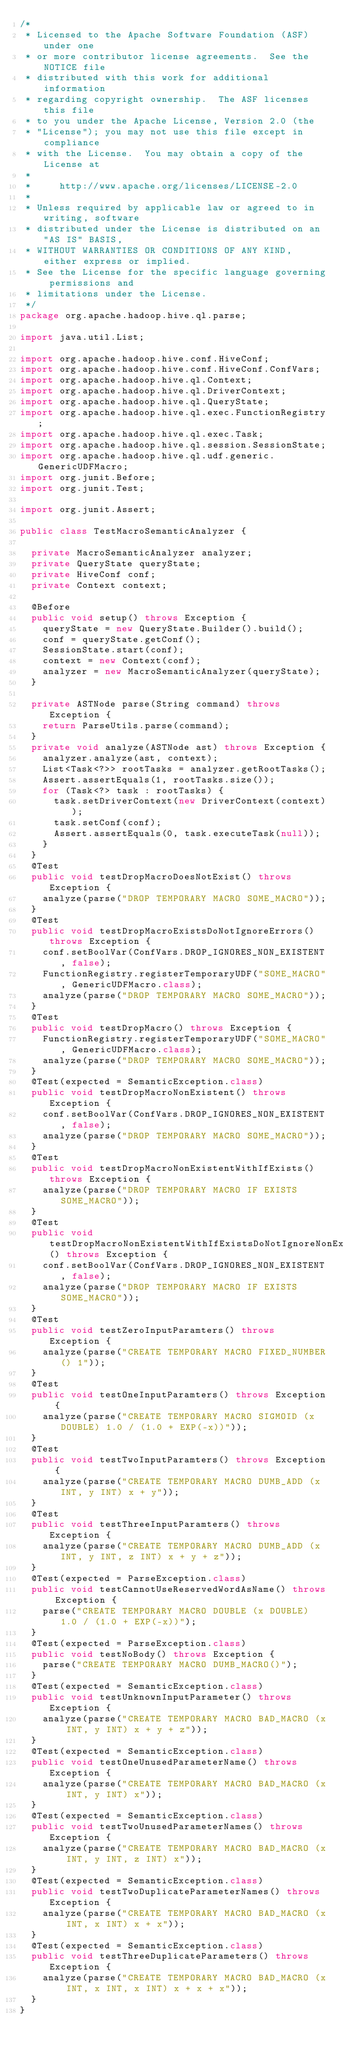Convert code to text. <code><loc_0><loc_0><loc_500><loc_500><_Java_>/*
 * Licensed to the Apache Software Foundation (ASF) under one
 * or more contributor license agreements.  See the NOTICE file
 * distributed with this work for additional information
 * regarding copyright ownership.  The ASF licenses this file
 * to you under the Apache License, Version 2.0 (the
 * "License"); you may not use this file except in compliance
 * with the License.  You may obtain a copy of the License at
 *
 *     http://www.apache.org/licenses/LICENSE-2.0
 *
 * Unless required by applicable law or agreed to in writing, software
 * distributed under the License is distributed on an "AS IS" BASIS,
 * WITHOUT WARRANTIES OR CONDITIONS OF ANY KIND, either express or implied.
 * See the License for the specific language governing permissions and
 * limitations under the License.
 */
package org.apache.hadoop.hive.ql.parse;

import java.util.List;

import org.apache.hadoop.hive.conf.HiveConf;
import org.apache.hadoop.hive.conf.HiveConf.ConfVars;
import org.apache.hadoop.hive.ql.Context;
import org.apache.hadoop.hive.ql.DriverContext;
import org.apache.hadoop.hive.ql.QueryState;
import org.apache.hadoop.hive.ql.exec.FunctionRegistry;
import org.apache.hadoop.hive.ql.exec.Task;
import org.apache.hadoop.hive.ql.session.SessionState;
import org.apache.hadoop.hive.ql.udf.generic.GenericUDFMacro;
import org.junit.Before;
import org.junit.Test;

import org.junit.Assert;

public class TestMacroSemanticAnalyzer {

  private MacroSemanticAnalyzer analyzer;
  private QueryState queryState;
  private HiveConf conf;
  private Context context;

  @Before
  public void setup() throws Exception {
    queryState = new QueryState.Builder().build();
    conf = queryState.getConf();
    SessionState.start(conf);
    context = new Context(conf);
    analyzer = new MacroSemanticAnalyzer(queryState);
  }

  private ASTNode parse(String command) throws Exception {
    return ParseUtils.parse(command);
  }
  private void analyze(ASTNode ast) throws Exception {
    analyzer.analyze(ast, context);
    List<Task<?>> rootTasks = analyzer.getRootTasks();
    Assert.assertEquals(1, rootTasks.size());
    for (Task<?> task : rootTasks) {
      task.setDriverContext(new DriverContext(context));
      task.setConf(conf);
      Assert.assertEquals(0, task.executeTask(null));
    }
  }
  @Test
  public void testDropMacroDoesNotExist() throws Exception {
    analyze(parse("DROP TEMPORARY MACRO SOME_MACRO"));
  }
  @Test
  public void testDropMacroExistsDoNotIgnoreErrors() throws Exception {
    conf.setBoolVar(ConfVars.DROP_IGNORES_NON_EXISTENT, false);
    FunctionRegistry.registerTemporaryUDF("SOME_MACRO", GenericUDFMacro.class);
    analyze(parse("DROP TEMPORARY MACRO SOME_MACRO"));
  }
  @Test
  public void testDropMacro() throws Exception {
    FunctionRegistry.registerTemporaryUDF("SOME_MACRO", GenericUDFMacro.class);
    analyze(parse("DROP TEMPORARY MACRO SOME_MACRO"));
  }
  @Test(expected = SemanticException.class)
  public void testDropMacroNonExistent() throws Exception {
    conf.setBoolVar(ConfVars.DROP_IGNORES_NON_EXISTENT, false);
    analyze(parse("DROP TEMPORARY MACRO SOME_MACRO"));
  }
  @Test
  public void testDropMacroNonExistentWithIfExists() throws Exception {
    analyze(parse("DROP TEMPORARY MACRO IF EXISTS SOME_MACRO"));
  }
  @Test
  public void testDropMacroNonExistentWithIfExistsDoNotIgnoreNonExistent() throws Exception {
    conf.setBoolVar(ConfVars.DROP_IGNORES_NON_EXISTENT, false);
    analyze(parse("DROP TEMPORARY MACRO IF EXISTS SOME_MACRO"));
  }
  @Test
  public void testZeroInputParamters() throws Exception {
    analyze(parse("CREATE TEMPORARY MACRO FIXED_NUMBER() 1"));
  }
  @Test
  public void testOneInputParamters() throws Exception {
    analyze(parse("CREATE TEMPORARY MACRO SIGMOID (x DOUBLE) 1.0 / (1.0 + EXP(-x))"));
  }
  @Test
  public void testTwoInputParamters() throws Exception {
    analyze(parse("CREATE TEMPORARY MACRO DUMB_ADD (x INT, y INT) x + y"));
  }
  @Test
  public void testThreeInputParamters() throws Exception {
    analyze(parse("CREATE TEMPORARY MACRO DUMB_ADD (x INT, y INT, z INT) x + y + z"));
  }
  @Test(expected = ParseException.class)
  public void testCannotUseReservedWordAsName() throws Exception {
    parse("CREATE TEMPORARY MACRO DOUBLE (x DOUBLE) 1.0 / (1.0 + EXP(-x))");
  }
  @Test(expected = ParseException.class)
  public void testNoBody() throws Exception {
    parse("CREATE TEMPORARY MACRO DUMB_MACRO()");
  }
  @Test(expected = SemanticException.class)
  public void testUnknownInputParameter() throws Exception {
    analyze(parse("CREATE TEMPORARY MACRO BAD_MACRO (x INT, y INT) x + y + z"));
  }
  @Test(expected = SemanticException.class)
  public void testOneUnusedParameterName() throws Exception {
    analyze(parse("CREATE TEMPORARY MACRO BAD_MACRO (x INT, y INT) x"));
  }
  @Test(expected = SemanticException.class)
  public void testTwoUnusedParameterNames() throws Exception {
    analyze(parse("CREATE TEMPORARY MACRO BAD_MACRO (x INT, y INT, z INT) x"));
  }
  @Test(expected = SemanticException.class)
  public void testTwoDuplicateParameterNames() throws Exception {
    analyze(parse("CREATE TEMPORARY MACRO BAD_MACRO (x INT, x INT) x + x"));
  }
  @Test(expected = SemanticException.class)
  public void testThreeDuplicateParameters() throws Exception {
    analyze(parse("CREATE TEMPORARY MACRO BAD_MACRO (x INT, x INT, x INT) x + x + x"));
  }
}</code> 